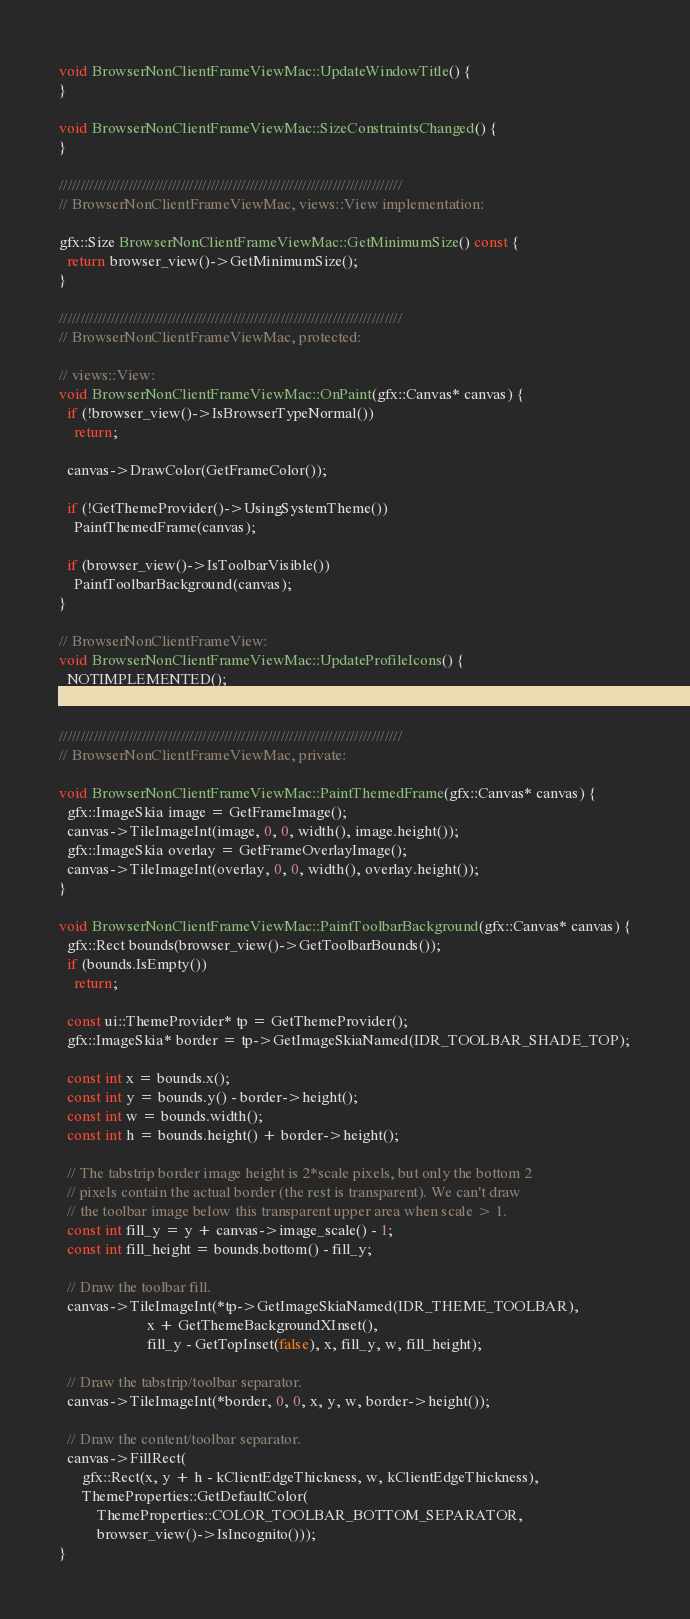Convert code to text. <code><loc_0><loc_0><loc_500><loc_500><_ObjectiveC_>void BrowserNonClientFrameViewMac::UpdateWindowTitle() {
}

void BrowserNonClientFrameViewMac::SizeConstraintsChanged() {
}

///////////////////////////////////////////////////////////////////////////////
// BrowserNonClientFrameViewMac, views::View implementation:

gfx::Size BrowserNonClientFrameViewMac::GetMinimumSize() const {
  return browser_view()->GetMinimumSize();
}

///////////////////////////////////////////////////////////////////////////////
// BrowserNonClientFrameViewMac, protected:

// views::View:
void BrowserNonClientFrameViewMac::OnPaint(gfx::Canvas* canvas) {
  if (!browser_view()->IsBrowserTypeNormal())
    return;

  canvas->DrawColor(GetFrameColor());

  if (!GetThemeProvider()->UsingSystemTheme())
    PaintThemedFrame(canvas);

  if (browser_view()->IsToolbarVisible())
    PaintToolbarBackground(canvas);
}

// BrowserNonClientFrameView:
void BrowserNonClientFrameViewMac::UpdateProfileIcons() {
  NOTIMPLEMENTED();
}

///////////////////////////////////////////////////////////////////////////////
// BrowserNonClientFrameViewMac, private:

void BrowserNonClientFrameViewMac::PaintThemedFrame(gfx::Canvas* canvas) {
  gfx::ImageSkia image = GetFrameImage();
  canvas->TileImageInt(image, 0, 0, width(), image.height());
  gfx::ImageSkia overlay = GetFrameOverlayImage();
  canvas->TileImageInt(overlay, 0, 0, width(), overlay.height());
}

void BrowserNonClientFrameViewMac::PaintToolbarBackground(gfx::Canvas* canvas) {
  gfx::Rect bounds(browser_view()->GetToolbarBounds());
  if (bounds.IsEmpty())
    return;

  const ui::ThemeProvider* tp = GetThemeProvider();
  gfx::ImageSkia* border = tp->GetImageSkiaNamed(IDR_TOOLBAR_SHADE_TOP);

  const int x = bounds.x();
  const int y = bounds.y() - border->height();
  const int w = bounds.width();
  const int h = bounds.height() + border->height();

  // The tabstrip border image height is 2*scale pixels, but only the bottom 2
  // pixels contain the actual border (the rest is transparent). We can't draw
  // the toolbar image below this transparent upper area when scale > 1.
  const int fill_y = y + canvas->image_scale() - 1;
  const int fill_height = bounds.bottom() - fill_y;

  // Draw the toolbar fill.
  canvas->TileImageInt(*tp->GetImageSkiaNamed(IDR_THEME_TOOLBAR),
                       x + GetThemeBackgroundXInset(),
                       fill_y - GetTopInset(false), x, fill_y, w, fill_height);

  // Draw the tabstrip/toolbar separator.
  canvas->TileImageInt(*border, 0, 0, x, y, w, border->height());

  // Draw the content/toolbar separator.
  canvas->FillRect(
      gfx::Rect(x, y + h - kClientEdgeThickness, w, kClientEdgeThickness),
      ThemeProperties::GetDefaultColor(
          ThemeProperties::COLOR_TOOLBAR_BOTTOM_SEPARATOR,
          browser_view()->IsIncognito()));
}
</code> 